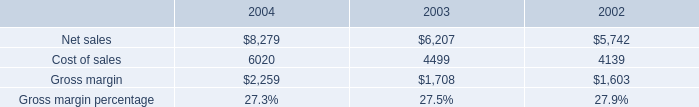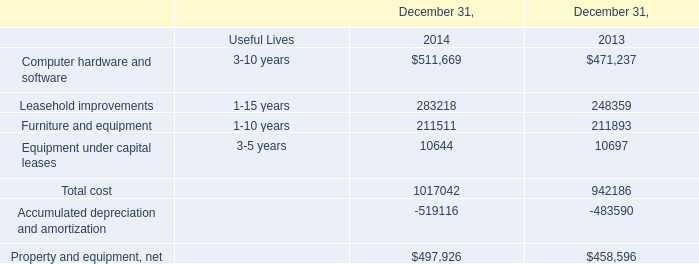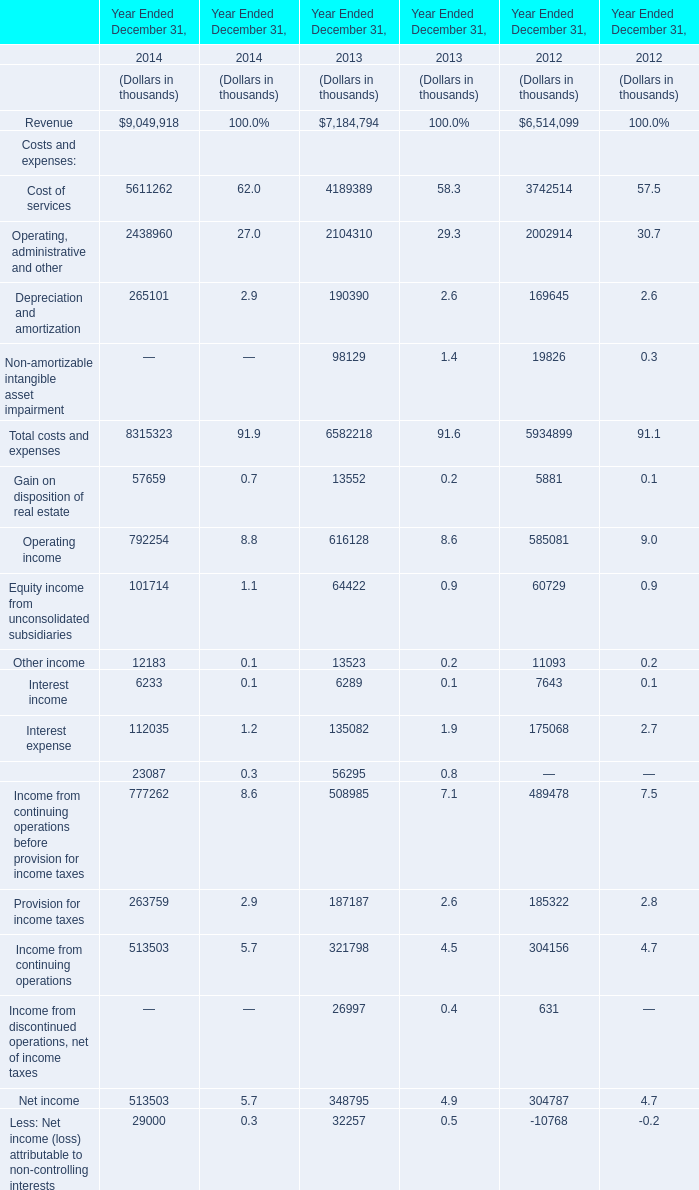Which year is Total costs and expenses the highest? 
Answer: 2014. 